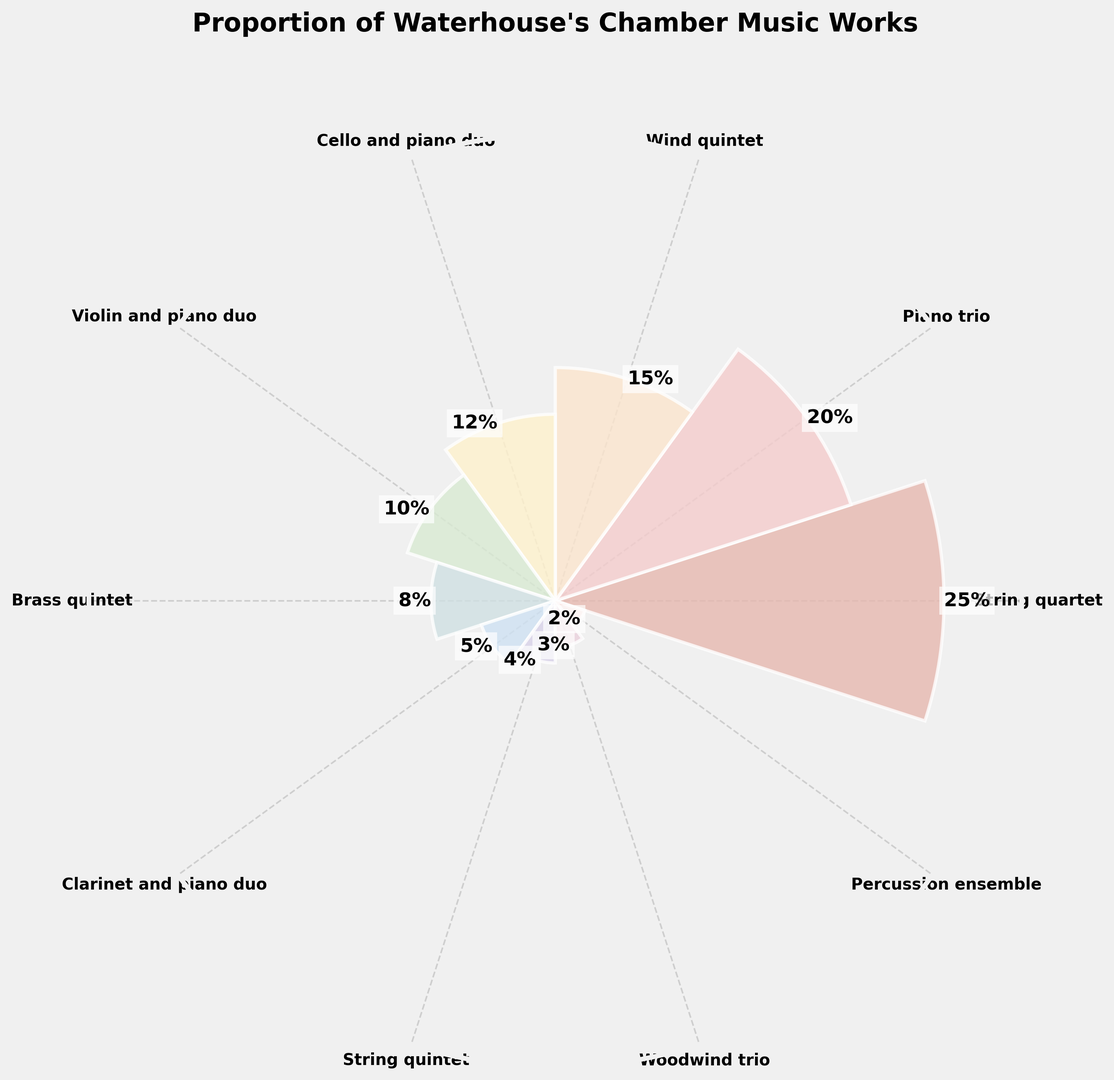What is the sum of the proportions for String quartet and Piano trio? Add the proportions for String quartet (25%) and Piano trio (20%) to find the total. 25% + 20% = 45%.
Answer: 45% Which instrument combination has the highest proportion? Compare each bar's height in the chart. The String quartet bar is the tallest, indicating it has the highest proportion at 25%.
Answer: String quartet What is the difference in proportion between Wind quintet and Brass quintet? Subtract the proportion of Brass quintet (8%) from the proportion of Wind quintet (15%). 15% - 8% = 7%.
Answer: 7% How many instrument combinations have a proportion greater than 10%? Identify and count the bars with a proportion higher than 10%. String quartet, Piano trio, Wind quintet, and Cello and piano duo. There are 4 such combinations.
Answer: 4 Which instrument combination has the least proportion? Compare each bar’s height. The Percussion ensemble bar is the shortest, indicating it has the least proportion at 2%.
Answer: Percussion ensemble What is the average proportion of the Violin and piano duo, Clarinet and piano duo, and String quintet? Sum the proportions of these combinations (10% + 5% + 4%) and then divide by 3. (10% + 5% + 4%) / 3 = 6.33%.
Answer: 6.33% Are there more chamber music works for Cello and piano duo or Violin and piano duo? Compare the heights of the bars for Cello and piano duo (12%) and Violin and piano duo (10%). Cello and piano duo has a higher proportion.
Answer: Cello and piano duo What is the proportion of chamber music works for combinations involving a piano? Identify and sum the proportions of combinations involving a piano: Piano trio (20%), Cello and piano duo (12%), Violin and piano duo (10%), and Clarinet and piano duo (5%). 20% + 12% + 10% + 5% = 47%.
Answer: 47% Which color represents the instrument combination with the highest proportion? Identify the color bar associated with the highest proportion, String quartet at 25%. The color associated with this bar in the figure is pale pink/light red.
Answer: Pale pink/light red What proportion of works does the Woodwind trio represent when compared to the total sum of all proportions? Given the individual proportions sum up to 100%, the Woodwind trio's proportion is 3% out of the total 100%.
Answer: 3% 